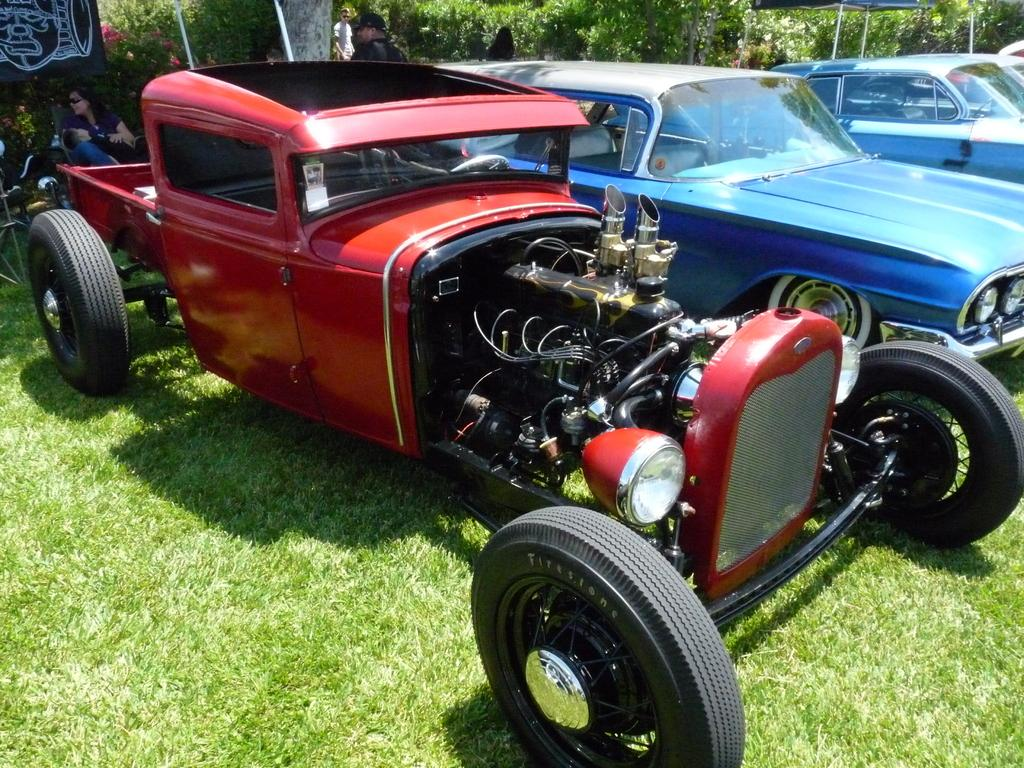What is located on the grass in the center of the image? There are cars on the grass in the center of the image. What can be seen in the background of the image? There are persons and trees present in the background of the image. What type of vegetation is visible in the background of the image? Plants are visible in the background of the image. What type of lace can be seen draped over the cars in the image? There is no lace present in the image; it features cars on the grass with no additional decorations. 